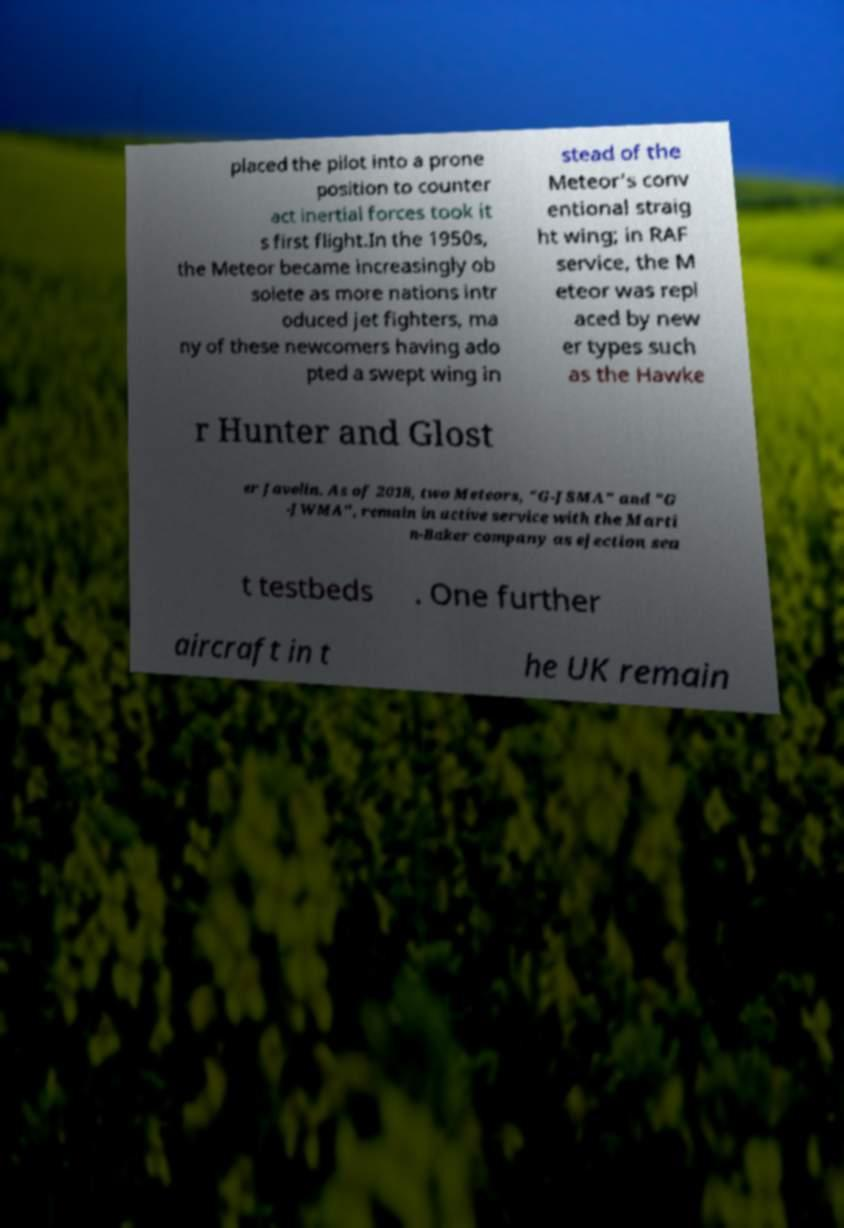Please identify and transcribe the text found in this image. placed the pilot into a prone position to counter act inertial forces took it s first flight.In the 1950s, the Meteor became increasingly ob solete as more nations intr oduced jet fighters, ma ny of these newcomers having ado pted a swept wing in stead of the Meteor's conv entional straig ht wing; in RAF service, the M eteor was repl aced by new er types such as the Hawke r Hunter and Glost er Javelin. As of 2018, two Meteors, "G-JSMA" and "G -JWMA", remain in active service with the Marti n-Baker company as ejection sea t testbeds . One further aircraft in t he UK remain 